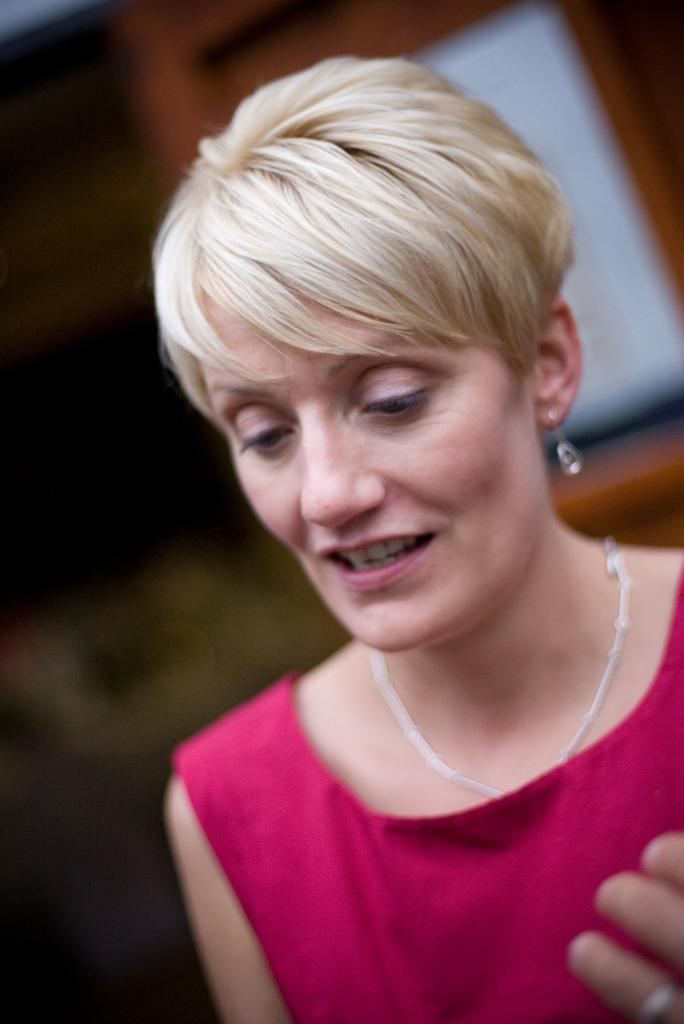What is the main subject of the image? There is a lady person in the image. What is the lady person wearing? The lady person is wearing a red dress and a necklace. What is the lady person doing in the image? The lady person is standing. What type of poison can be seen in the lady person's hand in the image? There is no poison present in the image; the lady person is not holding anything. 